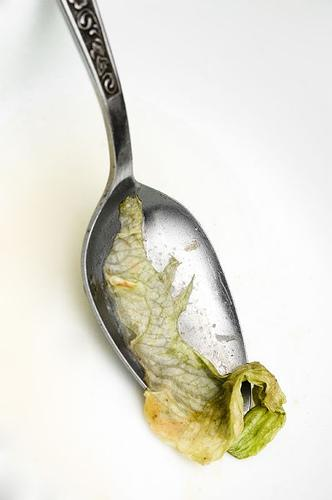Question: what is on the spoon?
Choices:
A. Food.
B. Medicine.
C. Water.
D. Butter.
Answer with the letter. Answer: A Question: why is the spoon there?
Choices:
A. Someone left it there.
B. To use.
C. It got up and walked there.
D. It was used and not put away.
Answer with the letter. Answer: B Question: how many spoons?
Choices:
A. 2.
B. 1.
C. 3.
D. 4.
Answer with the letter. Answer: B 